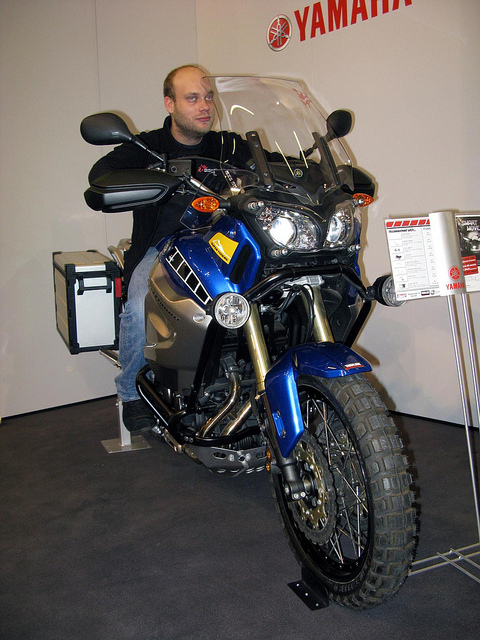Identify the text contained in this image. YAMA 